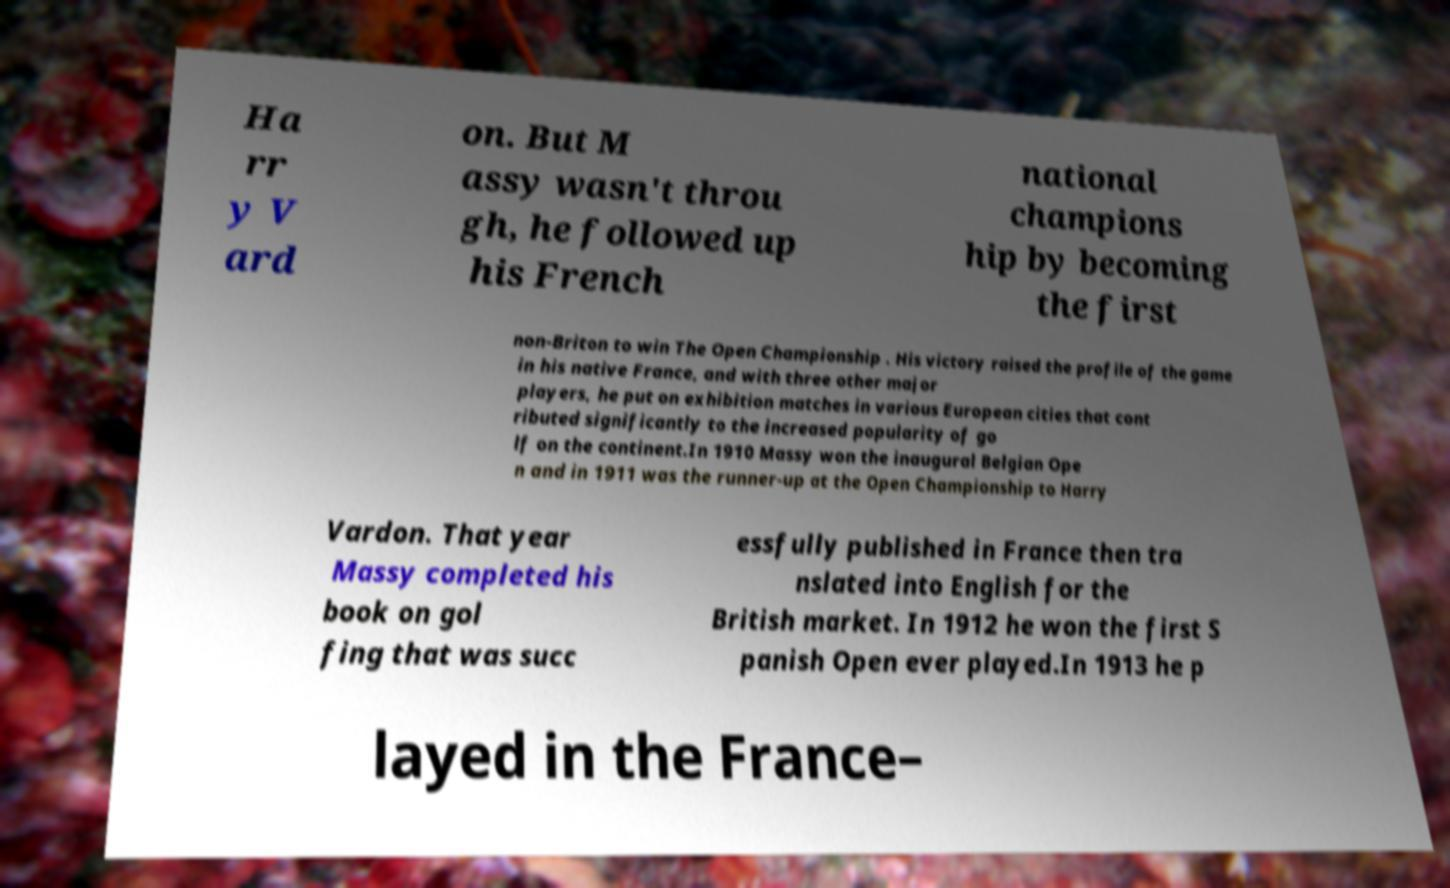Could you assist in decoding the text presented in this image and type it out clearly? Ha rr y V ard on. But M assy wasn't throu gh, he followed up his French national champions hip by becoming the first non-Briton to win The Open Championship . His victory raised the profile of the game in his native France, and with three other major players, he put on exhibition matches in various European cities that cont ributed significantly to the increased popularity of go lf on the continent.In 1910 Massy won the inaugural Belgian Ope n and in 1911 was the runner-up at the Open Championship to Harry Vardon. That year Massy completed his book on gol fing that was succ essfully published in France then tra nslated into English for the British market. In 1912 he won the first S panish Open ever played.In 1913 he p layed in the France– 